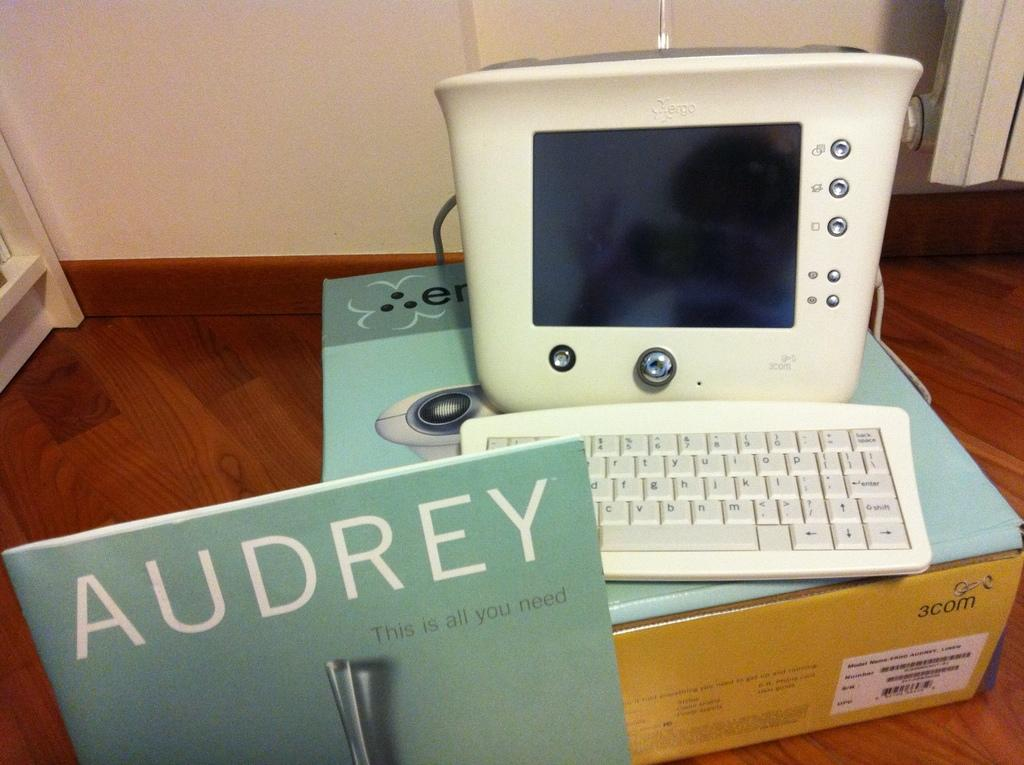<image>
Give a short and clear explanation of the subsequent image. A computer is on a box next to a book that says Audrey. 